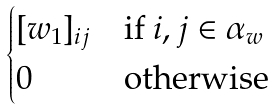<formula> <loc_0><loc_0><loc_500><loc_500>\begin{cases} [ { w } _ { 1 } ] _ { i j } & \text {if } i , j \in \alpha _ { w } \\ 0 & \text {otherwise} \end{cases}</formula> 